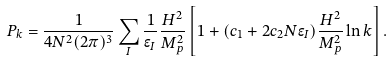<formula> <loc_0><loc_0><loc_500><loc_500>P _ { k } = \frac { 1 } { 4 N ^ { 2 } ( 2 \pi ) ^ { 3 } } \sum _ { I } \frac { 1 } { \epsilon _ { I } } \frac { H ^ { 2 } } { M _ { p } ^ { 2 } } \left [ 1 + ( c _ { 1 } + 2 c _ { 2 } N \epsilon _ { I } ) \frac { H ^ { 2 } } { M _ { p } ^ { 2 } } \ln k \right ] .</formula> 